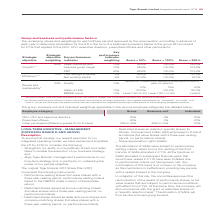According to Tiger Brands's financial document, Which strategic objective has the highest weightage? According to the financial document, Growth. The relevant text states: "Growth*,**..." Also, Some strategy has a '*', what does this strategy relate to? According to the financial document, budget. The relevant text states: "gets have not been provided as they are linked to budget and considered commercially sensitive information. ** For the key performance indicators within the..." Also, can you calculate: How much does net working capital account for in Efficiency?  Based on the calculation: 5%/10%, the result is 50 (percentage). This is based on the information: "weighting Score = 50% Score = 100% Score = 200% weighting Score = 50% Score = 100% Score = 200%..." The key data points involved are: 10. Additionally, Which key performance indicator accounts for two thirds in Growth? According to the financial document, PBIT. The relevant text states: "PBIT 40% 98,6% 100,0% 103,6%..." Also, Why haven't the actual targets been provided? As they are linked to budget and considered commercially sensitive information. The document states: "* The actual targets have not been provided as they are linked to budget and considered commercially sensitive information. ** For the key performance..." Also, To whom did the group STI scorecard for FY19 apply? the CEO, CFO, executive directors, prescribed officers and other participants. The document states: "the group STI scorecard for FY19 that applied to the CEO, CFO, executive directors, prescribed officers and other participants:..." Also, How many key performance indicators that have the same weightage of 10%? Counting the relevant items in the document: Sales volume growth, Absolute gross margin, Quality, Safety (LTIFR), BBBEE score, I find 5 instances. The key data points involved are: Absolute gross margin, BBBEE score, Quality. 